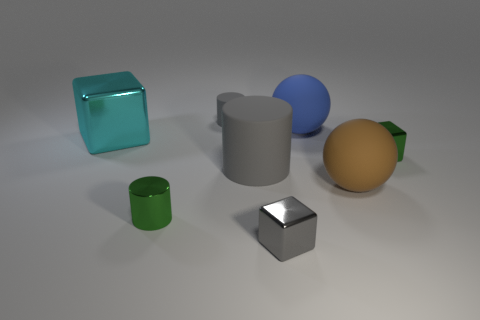Does the large rubber cylinder have the same color as the tiny rubber thing?
Offer a terse response. Yes. What material is the other gray object that is the same shape as the big gray matte thing?
Offer a very short reply. Rubber. Are there fewer large brown objects that are to the left of the green block than big brown metal spheres?
Offer a very short reply. No. There is a tiny green thing that is behind the cylinder that is on the left side of the tiny cylinder behind the large metallic object; what is its shape?
Your answer should be compact. Cube. There is a metallic block that is to the left of the gray metallic block; how big is it?
Give a very brief answer. Large. The brown rubber object that is the same size as the cyan cube is what shape?
Provide a short and direct response. Sphere. What number of objects are either small cubes or shiny cubes that are right of the small gray block?
Your answer should be compact. 2. How many large blue spheres are behind the tiny green metallic object on the left side of the matte sphere that is behind the brown ball?
Your answer should be very brief. 1. There is a tiny cylinder that is made of the same material as the cyan cube; what is its color?
Your response must be concise. Green. Do the metal thing in front of the shiny cylinder and the large gray thing have the same size?
Your answer should be very brief. No. 